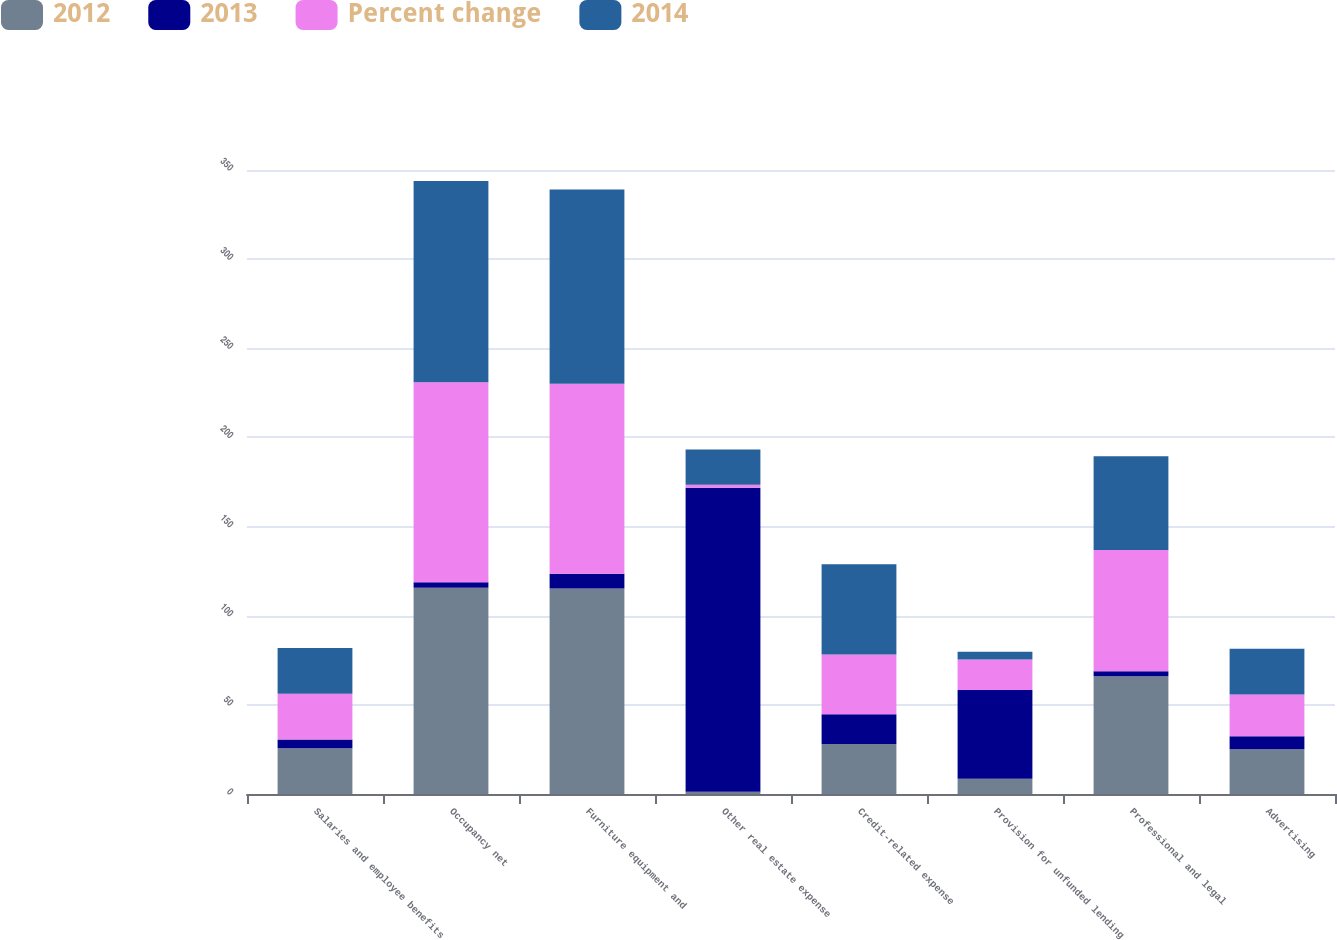Convert chart to OTSL. <chart><loc_0><loc_0><loc_500><loc_500><stacked_bar_chart><ecel><fcel>Salaries and employee benefits<fcel>Occupancy net<fcel>Furniture equipment and<fcel>Other real estate expense<fcel>Credit-related expense<fcel>Provision for unfunded lending<fcel>Professional and legal<fcel>Advertising<nl><fcel>2012<fcel>25.7<fcel>115.7<fcel>115.3<fcel>1.2<fcel>28<fcel>8.6<fcel>66<fcel>25.1<nl><fcel>2013<fcel>4.8<fcel>3<fcel>8.2<fcel>170.6<fcel>16.7<fcel>49.7<fcel>2.9<fcel>7.3<nl><fcel>Percent change<fcel>25.7<fcel>112.3<fcel>106.6<fcel>1.7<fcel>33.6<fcel>17.1<fcel>68<fcel>23.4<nl><fcel>2014<fcel>25.7<fcel>112.9<fcel>109<fcel>19.7<fcel>50.5<fcel>4.4<fcel>52.5<fcel>25.7<nl></chart> 